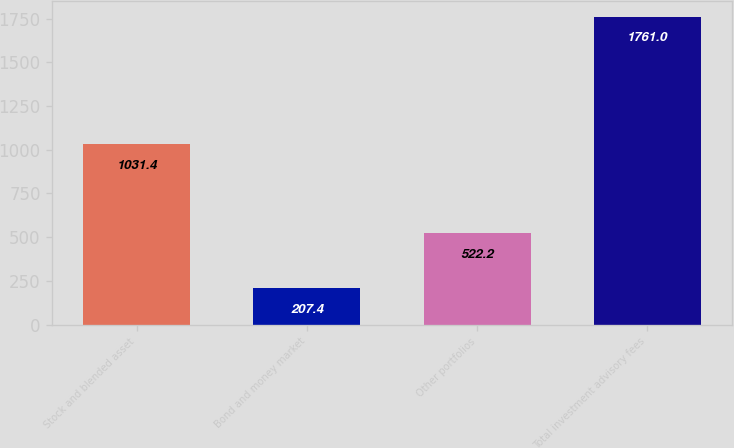Convert chart to OTSL. <chart><loc_0><loc_0><loc_500><loc_500><bar_chart><fcel>Stock and blended asset<fcel>Bond and money market<fcel>Other portfolios<fcel>Total investment advisory fees<nl><fcel>1031.4<fcel>207.4<fcel>522.2<fcel>1761<nl></chart> 